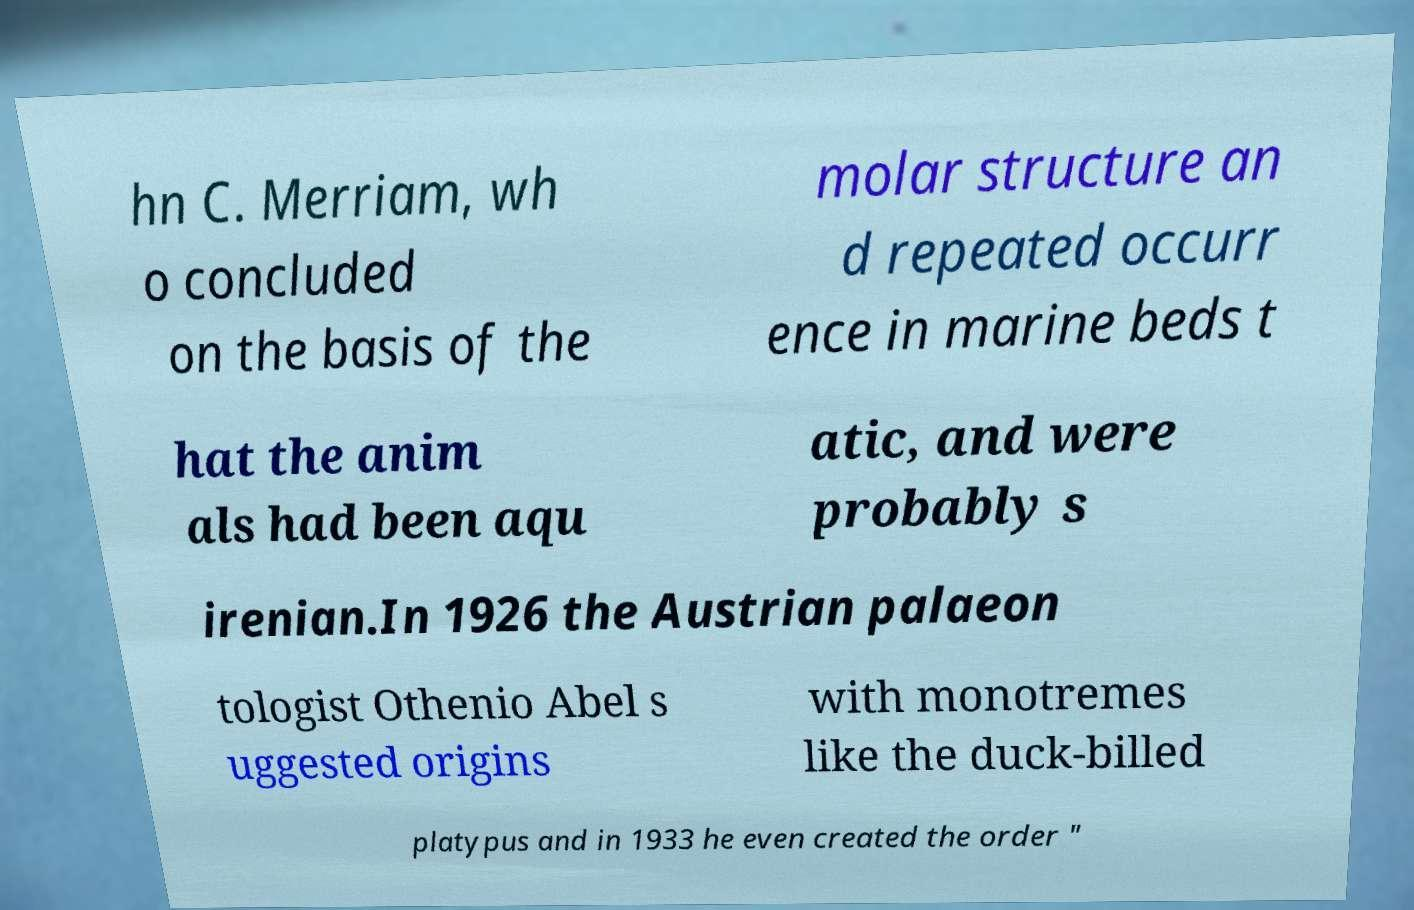There's text embedded in this image that I need extracted. Can you transcribe it verbatim? hn C. Merriam, wh o concluded on the basis of the molar structure an d repeated occurr ence in marine beds t hat the anim als had been aqu atic, and were probably s irenian.In 1926 the Austrian palaeon tologist Othenio Abel s uggested origins with monotremes like the duck-billed platypus and in 1933 he even created the order " 